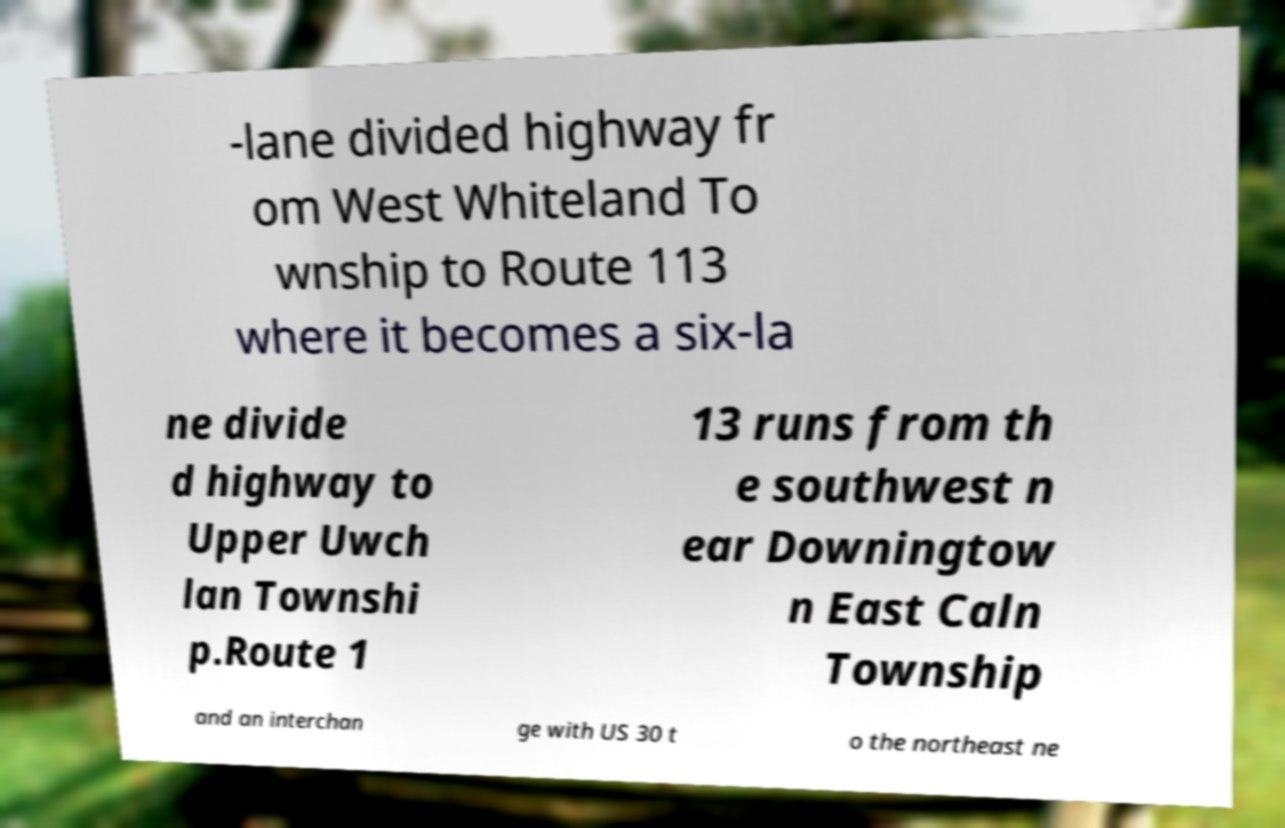There's text embedded in this image that I need extracted. Can you transcribe it verbatim? -lane divided highway fr om West Whiteland To wnship to Route 113 where it becomes a six-la ne divide d highway to Upper Uwch lan Townshi p.Route 1 13 runs from th e southwest n ear Downingtow n East Caln Township and an interchan ge with US 30 t o the northeast ne 